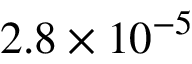<formula> <loc_0><loc_0><loc_500><loc_500>2 . 8 \times 1 0 ^ { - 5 }</formula> 